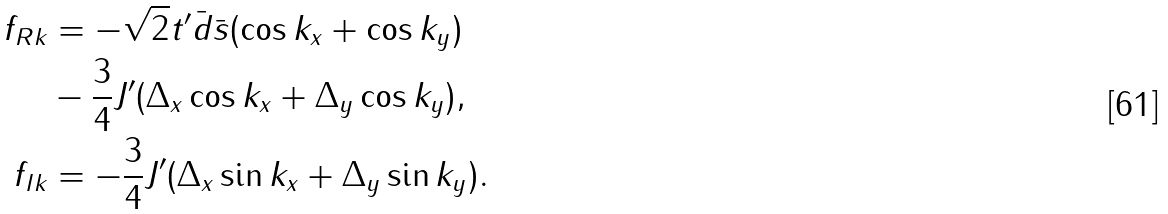<formula> <loc_0><loc_0><loc_500><loc_500>f _ { R k } & = - \sqrt { 2 } t ^ { \prime } \bar { d } \bar { s } ( \cos { k _ { x } } + \cos { k _ { y } } ) \\ & - \frac { 3 } { 4 } J ^ { \prime } ( \Delta _ { x } \cos { k _ { x } } + \Delta _ { y } \cos { k _ { y } } ) , \\ f _ { I k } & = - \frac { 3 } { 4 } J ^ { \prime } ( \Delta _ { x } \sin { k _ { x } } + \Delta _ { y } \sin { k _ { y } } ) .</formula> 